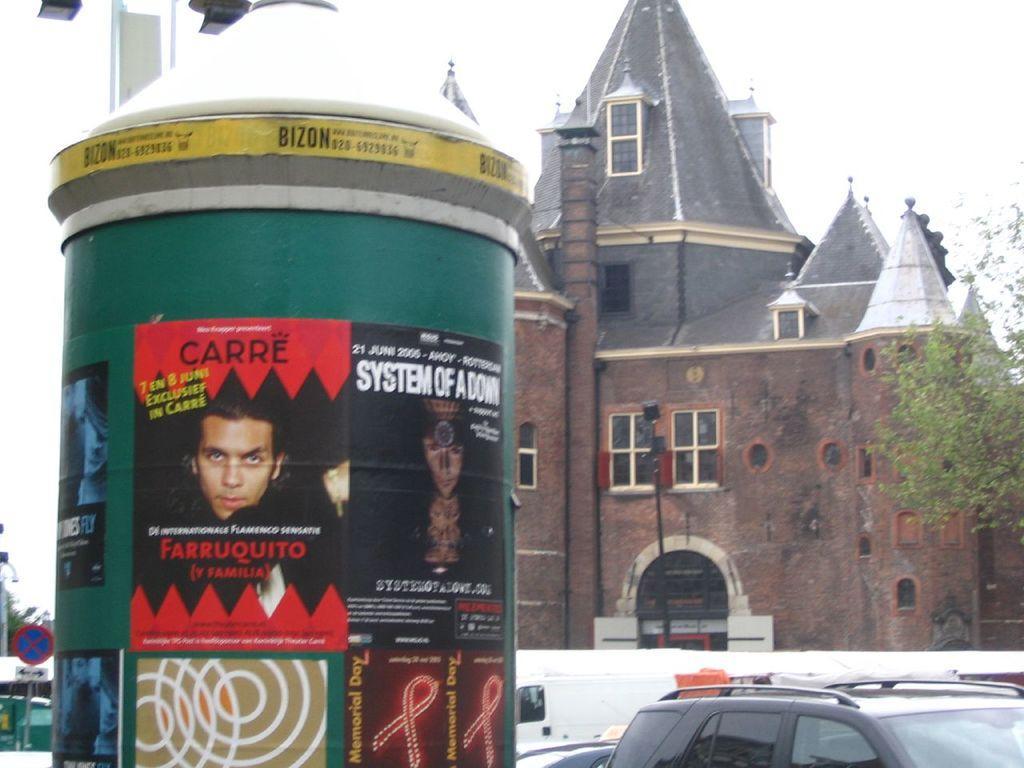Please provide a concise description of this image. In this image in the front there is a pillar with some text written on it and with some posters. In the center there are vehicles and in the background there is a castle and on the right side there are leaves. On the left side there is a sign board and in the background there are leaves which are visible and there is an object which is green in colour. 